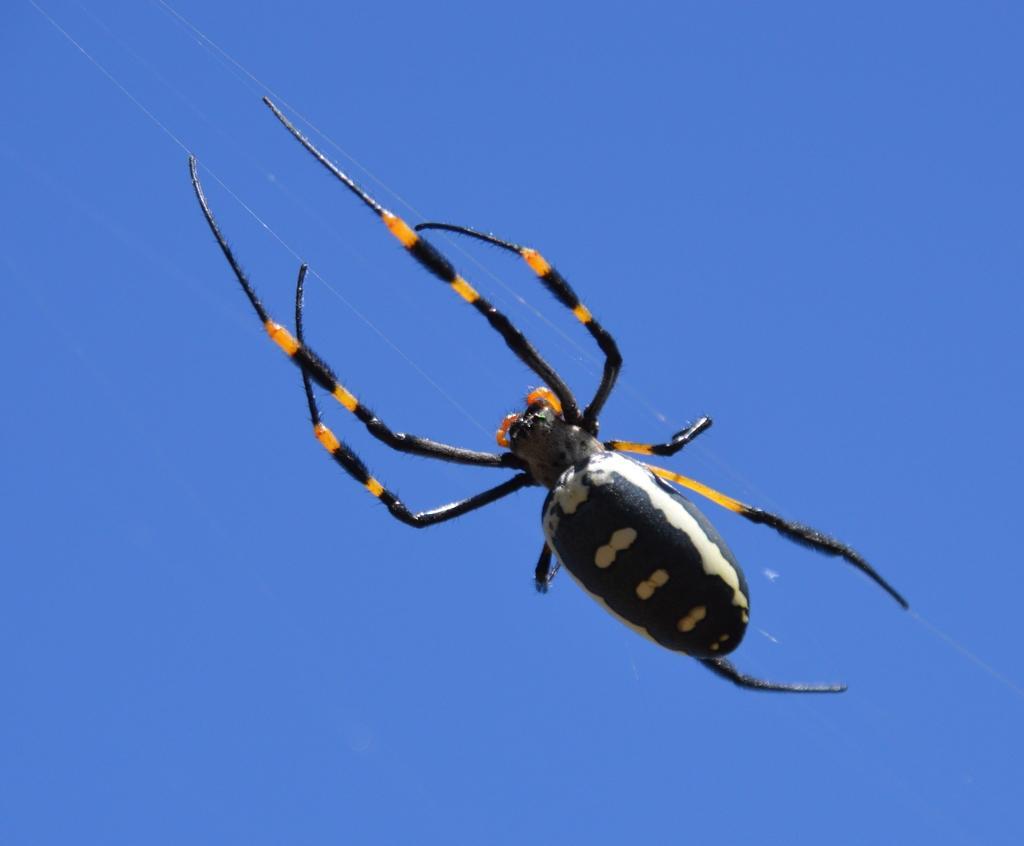How would you summarize this image in a sentence or two? In the picture I can see a spider. The background the image is blue in color. 